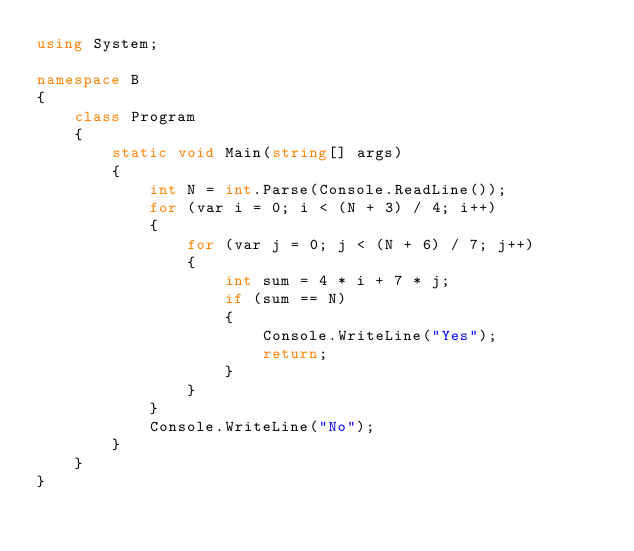<code> <loc_0><loc_0><loc_500><loc_500><_C#_>using System;

namespace B
{
    class Program
    {
        static void Main(string[] args)
        {
            int N = int.Parse(Console.ReadLine());
            for (var i = 0; i < (N + 3) / 4; i++)
            {
                for (var j = 0; j < (N + 6) / 7; j++)
                {
                    int sum = 4 * i + 7 * j;
                    if (sum == N)
                    {
                        Console.WriteLine("Yes");
                        return;
                    }
                }
            }
            Console.WriteLine("No");
        }
    }
}
</code> 